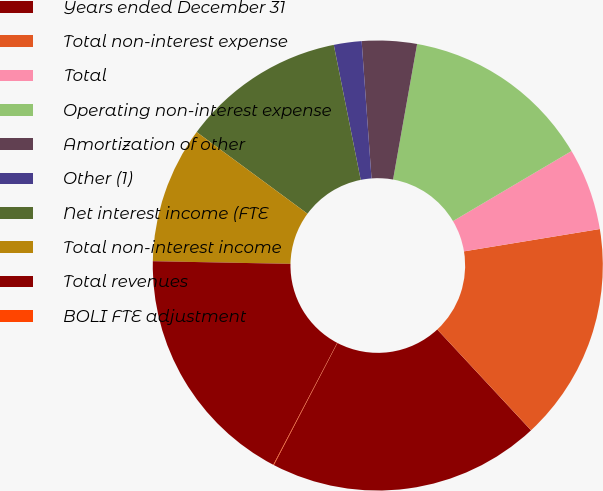<chart> <loc_0><loc_0><loc_500><loc_500><pie_chart><fcel>Years ended December 31<fcel>Total non-interest expense<fcel>Total<fcel>Operating non-interest expense<fcel>Amortization of other<fcel>Other (1)<fcel>Net interest income (FTE<fcel>Total non-interest income<fcel>Total revenues<fcel>BOLI FTE adjustment<nl><fcel>19.57%<fcel>15.67%<fcel>5.9%<fcel>13.71%<fcel>3.94%<fcel>1.99%<fcel>11.76%<fcel>9.8%<fcel>17.62%<fcel>0.04%<nl></chart> 